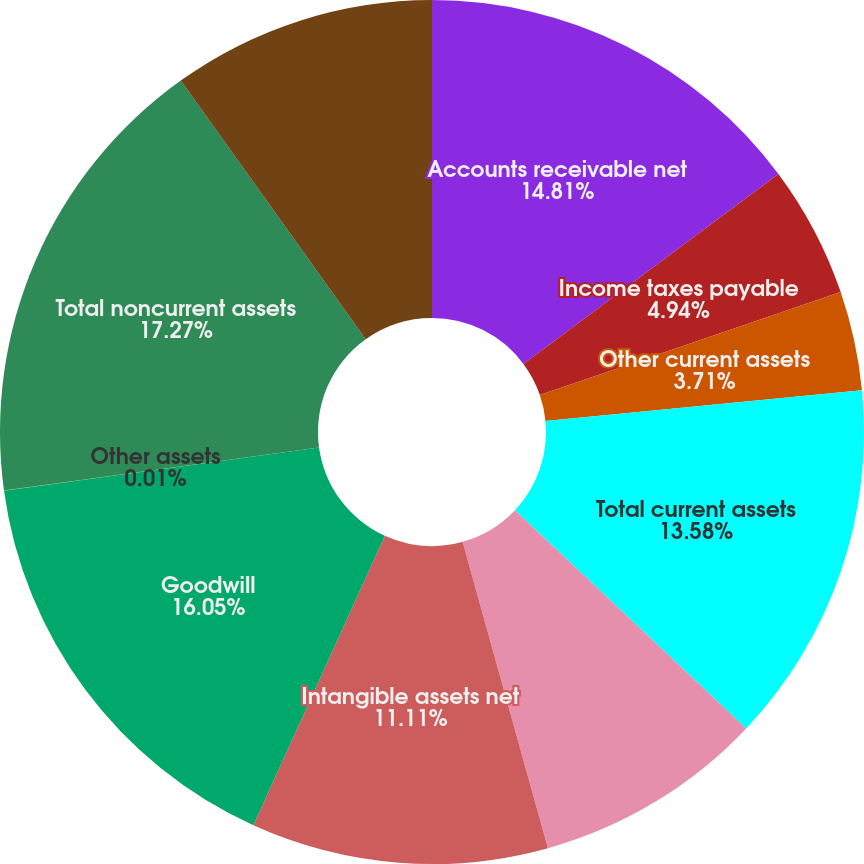Convert chart to OTSL. <chart><loc_0><loc_0><loc_500><loc_500><pie_chart><fcel>Accounts receivable net<fcel>Income taxes payable<fcel>Other current assets<fcel>Total current assets<fcel>Fixed assets net<fcel>Intangible assets net<fcel>Goodwill<fcel>Other assets<fcel>Total noncurrent assets<fcel>Accounts payable and accrued<nl><fcel>14.81%<fcel>4.94%<fcel>3.71%<fcel>13.58%<fcel>8.64%<fcel>11.11%<fcel>16.05%<fcel>0.01%<fcel>17.28%<fcel>9.88%<nl></chart> 